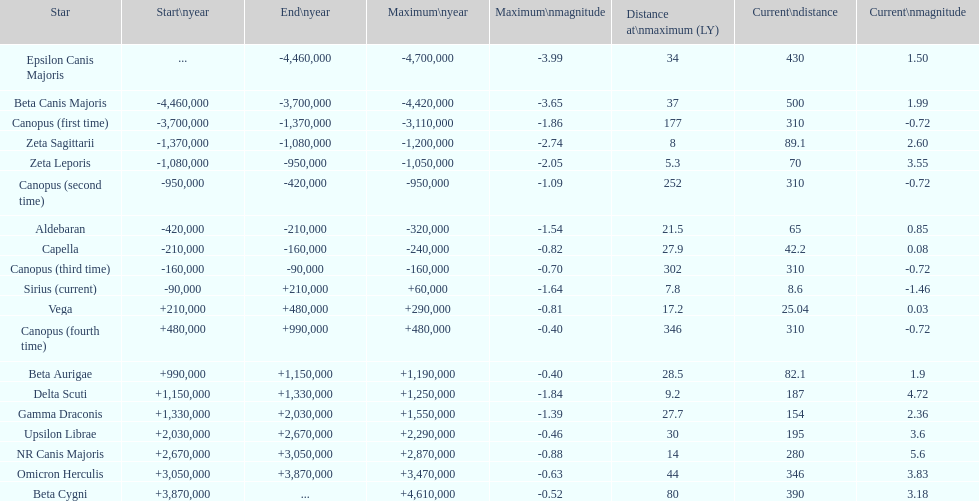How many stars have a magnitude exceeding zero? 14. 